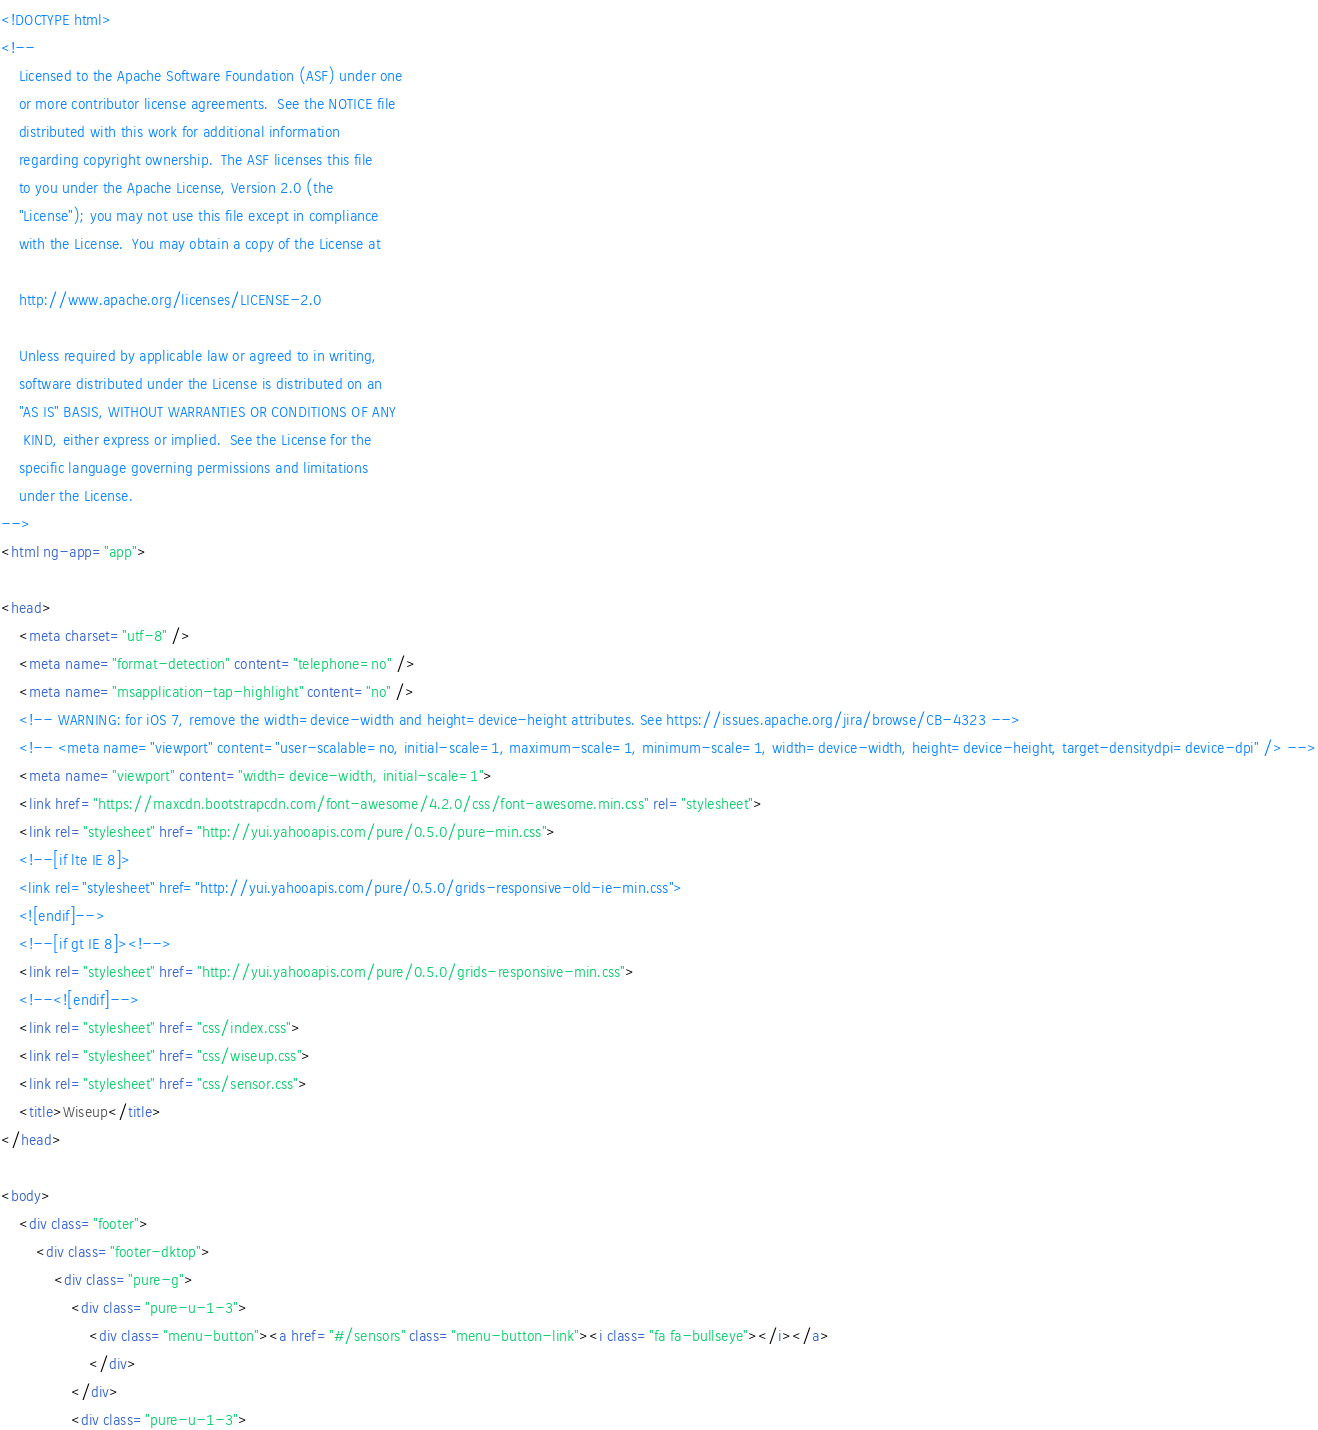Convert code to text. <code><loc_0><loc_0><loc_500><loc_500><_HTML_><!DOCTYPE html>
<!--
    Licensed to the Apache Software Foundation (ASF) under one
    or more contributor license agreements.  See the NOTICE file
    distributed with this work for additional information
    regarding copyright ownership.  The ASF licenses this file
    to you under the Apache License, Version 2.0 (the
    "License"); you may not use this file except in compliance
    with the License.  You may obtain a copy of the License at

    http://www.apache.org/licenses/LICENSE-2.0

    Unless required by applicable law or agreed to in writing,
    software distributed under the License is distributed on an
    "AS IS" BASIS, WITHOUT WARRANTIES OR CONDITIONS OF ANY
     KIND, either express or implied.  See the License for the
    specific language governing permissions and limitations
    under the License.
-->
<html ng-app="app">

<head>
    <meta charset="utf-8" />
    <meta name="format-detection" content="telephone=no" />
    <meta name="msapplication-tap-highlight" content="no" />
    <!-- WARNING: for iOS 7, remove the width=device-width and height=device-height attributes. See https://issues.apache.org/jira/browse/CB-4323 -->
    <!-- <meta name="viewport" content="user-scalable=no, initial-scale=1, maximum-scale=1, minimum-scale=1, width=device-width, height=device-height, target-densitydpi=device-dpi" /> -->
    <meta name="viewport" content="width=device-width, initial-scale=1">
    <link href="https://maxcdn.bootstrapcdn.com/font-awesome/4.2.0/css/font-awesome.min.css" rel="stylesheet">
    <link rel="stylesheet" href="http://yui.yahooapis.com/pure/0.5.0/pure-min.css">
    <!--[if lte IE 8]>
    <link rel="stylesheet" href="http://yui.yahooapis.com/pure/0.5.0/grids-responsive-old-ie-min.css">
    <![endif]-->
    <!--[if gt IE 8]><!-->
    <link rel="stylesheet" href="http://yui.yahooapis.com/pure/0.5.0/grids-responsive-min.css">
    <!--<![endif]-->
    <link rel="stylesheet" href="css/index.css">
    <link rel="stylesheet" href="css/wiseup.css">
    <link rel="stylesheet" href="css/sensor.css">
    <title>Wiseup</title>
</head>

<body>
    <div class="footer">
        <div class="footer-dktop">
            <div class="pure-g">
                <div class="pure-u-1-3">
                    <div class="menu-button"><a href="#/sensors" class="menu-button-link"><i class="fa fa-bullseye"></i></a>
                    </div>
                </div>
                <div class="pure-u-1-3"></code> 